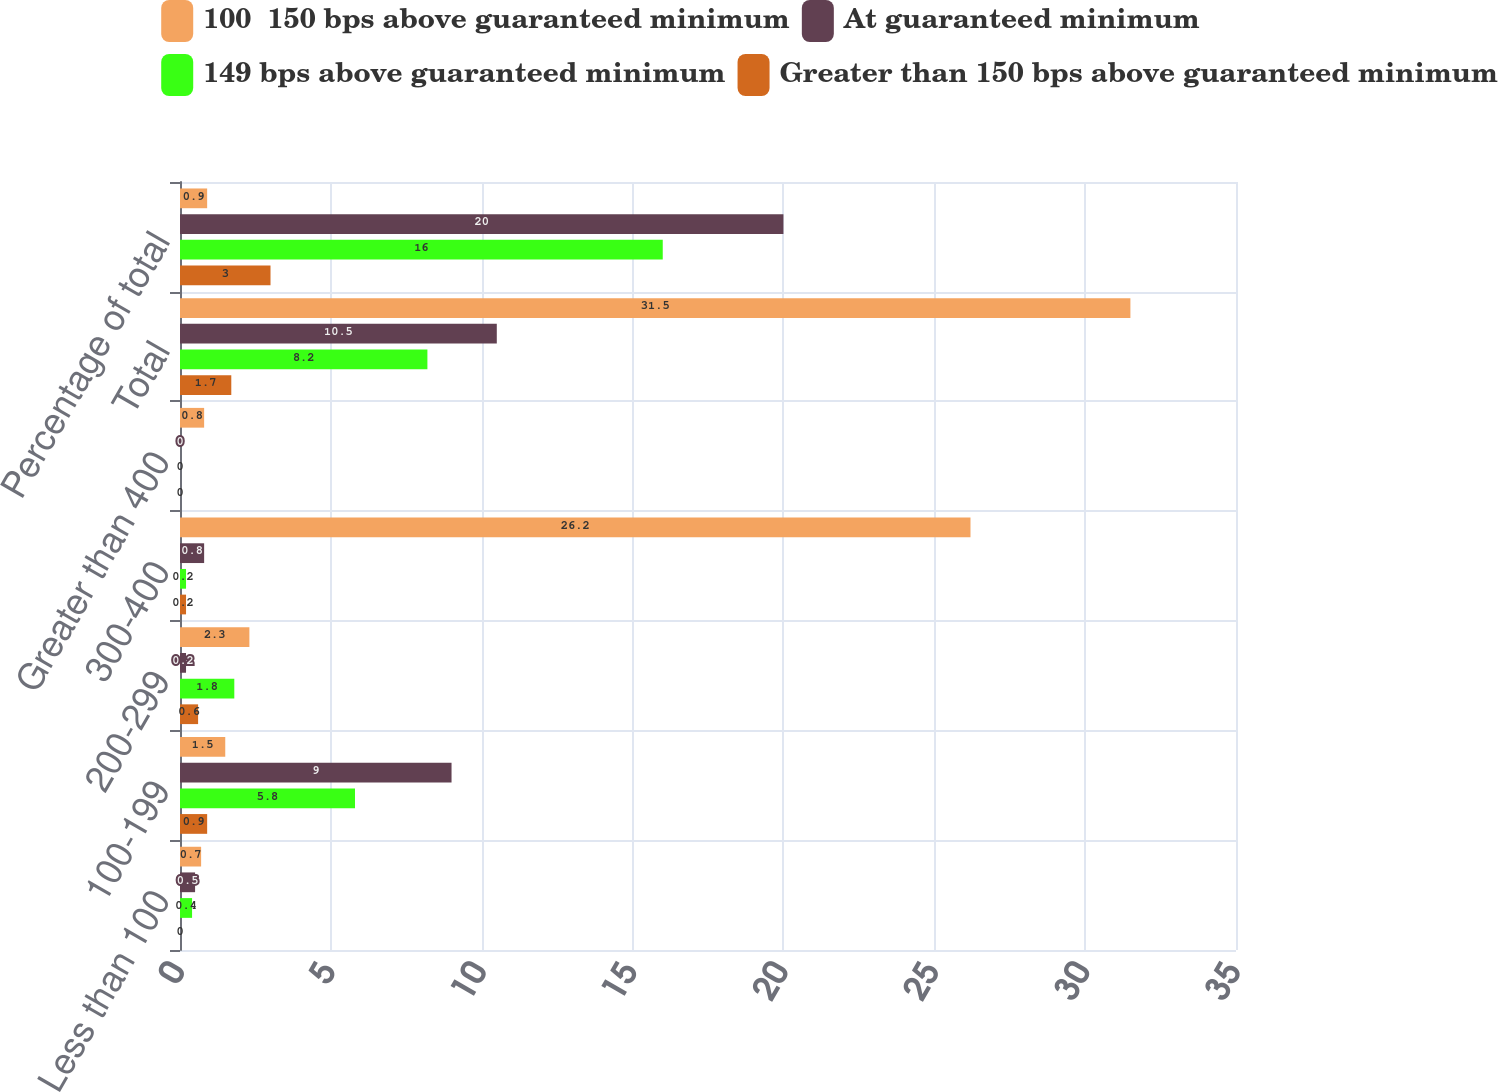<chart> <loc_0><loc_0><loc_500><loc_500><stacked_bar_chart><ecel><fcel>Less than 100<fcel>100-199<fcel>200-299<fcel>300-400<fcel>Greater than 400<fcel>Total<fcel>Percentage of total<nl><fcel>100  150 bps above guaranteed minimum<fcel>0.7<fcel>1.5<fcel>2.3<fcel>26.2<fcel>0.8<fcel>31.5<fcel>0.9<nl><fcel>At guaranteed minimum<fcel>0.5<fcel>9<fcel>0.2<fcel>0.8<fcel>0<fcel>10.5<fcel>20<nl><fcel>149 bps above guaranteed minimum<fcel>0.4<fcel>5.8<fcel>1.8<fcel>0.2<fcel>0<fcel>8.2<fcel>16<nl><fcel>Greater than 150 bps above guaranteed minimum<fcel>0<fcel>0.9<fcel>0.6<fcel>0.2<fcel>0<fcel>1.7<fcel>3<nl></chart> 